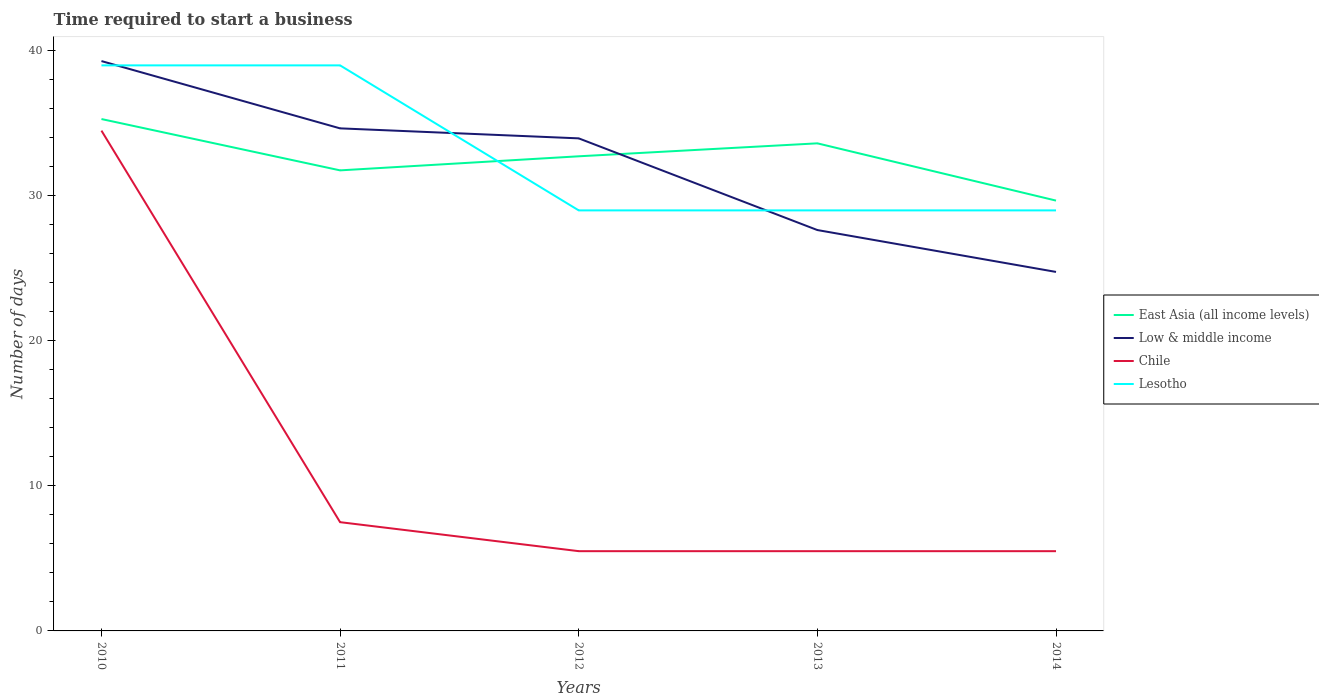How many different coloured lines are there?
Your answer should be very brief. 4. Is the number of lines equal to the number of legend labels?
Your answer should be very brief. Yes. Across all years, what is the maximum number of days required to start a business in East Asia (all income levels)?
Your answer should be compact. 29.68. What is the total number of days required to start a business in Low & middle income in the graph?
Your answer should be very brief. 5.33. Is the number of days required to start a business in Low & middle income strictly greater than the number of days required to start a business in Lesotho over the years?
Provide a short and direct response. No. How many lines are there?
Provide a succinct answer. 4. What is the difference between two consecutive major ticks on the Y-axis?
Your answer should be compact. 10. Are the values on the major ticks of Y-axis written in scientific E-notation?
Your answer should be very brief. No. Does the graph contain grids?
Give a very brief answer. No. How many legend labels are there?
Ensure brevity in your answer.  4. What is the title of the graph?
Offer a very short reply. Time required to start a business. Does "Isle of Man" appear as one of the legend labels in the graph?
Give a very brief answer. No. What is the label or title of the X-axis?
Offer a terse response. Years. What is the label or title of the Y-axis?
Your answer should be compact. Number of days. What is the Number of days in East Asia (all income levels) in 2010?
Provide a short and direct response. 35.3. What is the Number of days in Low & middle income in 2010?
Give a very brief answer. 39.3. What is the Number of days of Chile in 2010?
Your answer should be very brief. 34.5. What is the Number of days of Lesotho in 2010?
Provide a short and direct response. 39. What is the Number of days in East Asia (all income levels) in 2011?
Ensure brevity in your answer.  31.76. What is the Number of days of Low & middle income in 2011?
Offer a terse response. 34.66. What is the Number of days in Chile in 2011?
Provide a succinct answer. 7.5. What is the Number of days of East Asia (all income levels) in 2012?
Offer a very short reply. 32.73. What is the Number of days in Low & middle income in 2012?
Provide a short and direct response. 33.97. What is the Number of days in Chile in 2012?
Give a very brief answer. 5.5. What is the Number of days of East Asia (all income levels) in 2013?
Make the answer very short. 33.62. What is the Number of days in Low & middle income in 2013?
Your answer should be compact. 27.64. What is the Number of days in Chile in 2013?
Ensure brevity in your answer.  5.5. What is the Number of days of Lesotho in 2013?
Make the answer very short. 29. What is the Number of days of East Asia (all income levels) in 2014?
Offer a terse response. 29.68. What is the Number of days in Low & middle income in 2014?
Offer a terse response. 24.76. What is the Number of days of Lesotho in 2014?
Make the answer very short. 29. Across all years, what is the maximum Number of days of East Asia (all income levels)?
Your answer should be very brief. 35.3. Across all years, what is the maximum Number of days in Low & middle income?
Provide a short and direct response. 39.3. Across all years, what is the maximum Number of days in Chile?
Offer a very short reply. 34.5. Across all years, what is the maximum Number of days in Lesotho?
Provide a succinct answer. 39. Across all years, what is the minimum Number of days of East Asia (all income levels)?
Your answer should be compact. 29.68. Across all years, what is the minimum Number of days of Low & middle income?
Your answer should be compact. 24.76. What is the total Number of days in East Asia (all income levels) in the graph?
Provide a succinct answer. 163.09. What is the total Number of days in Low & middle income in the graph?
Offer a terse response. 160.32. What is the total Number of days in Chile in the graph?
Make the answer very short. 58.5. What is the total Number of days in Lesotho in the graph?
Make the answer very short. 165. What is the difference between the Number of days in East Asia (all income levels) in 2010 and that in 2011?
Your answer should be compact. 3.54. What is the difference between the Number of days in Low & middle income in 2010 and that in 2011?
Give a very brief answer. 4.64. What is the difference between the Number of days in Lesotho in 2010 and that in 2011?
Your answer should be very brief. 0. What is the difference between the Number of days of East Asia (all income levels) in 2010 and that in 2012?
Ensure brevity in your answer.  2.57. What is the difference between the Number of days in Low & middle income in 2010 and that in 2012?
Provide a short and direct response. 5.33. What is the difference between the Number of days of Chile in 2010 and that in 2012?
Keep it short and to the point. 29. What is the difference between the Number of days of Lesotho in 2010 and that in 2012?
Your response must be concise. 10. What is the difference between the Number of days in East Asia (all income levels) in 2010 and that in 2013?
Your response must be concise. 1.68. What is the difference between the Number of days in Low & middle income in 2010 and that in 2013?
Your response must be concise. 11.65. What is the difference between the Number of days in Chile in 2010 and that in 2013?
Your response must be concise. 29. What is the difference between the Number of days of Lesotho in 2010 and that in 2013?
Make the answer very short. 10. What is the difference between the Number of days in East Asia (all income levels) in 2010 and that in 2014?
Your response must be concise. 5.62. What is the difference between the Number of days of Low & middle income in 2010 and that in 2014?
Your answer should be very brief. 14.54. What is the difference between the Number of days in Lesotho in 2010 and that in 2014?
Make the answer very short. 10. What is the difference between the Number of days in East Asia (all income levels) in 2011 and that in 2012?
Keep it short and to the point. -0.97. What is the difference between the Number of days in Low & middle income in 2011 and that in 2012?
Ensure brevity in your answer.  0.69. What is the difference between the Number of days of Chile in 2011 and that in 2012?
Offer a terse response. 2. What is the difference between the Number of days of Lesotho in 2011 and that in 2012?
Your answer should be compact. 10. What is the difference between the Number of days in East Asia (all income levels) in 2011 and that in 2013?
Make the answer very short. -1.86. What is the difference between the Number of days in Low & middle income in 2011 and that in 2013?
Offer a very short reply. 7.01. What is the difference between the Number of days of Chile in 2011 and that in 2013?
Give a very brief answer. 2. What is the difference between the Number of days of Lesotho in 2011 and that in 2013?
Provide a succinct answer. 10. What is the difference between the Number of days in East Asia (all income levels) in 2011 and that in 2014?
Your response must be concise. 2.08. What is the difference between the Number of days in Low & middle income in 2011 and that in 2014?
Make the answer very short. 9.9. What is the difference between the Number of days of Chile in 2011 and that in 2014?
Ensure brevity in your answer.  2. What is the difference between the Number of days of Lesotho in 2011 and that in 2014?
Provide a succinct answer. 10. What is the difference between the Number of days of East Asia (all income levels) in 2012 and that in 2013?
Make the answer very short. -0.89. What is the difference between the Number of days of Low & middle income in 2012 and that in 2013?
Offer a terse response. 6.32. What is the difference between the Number of days in Lesotho in 2012 and that in 2013?
Provide a short and direct response. 0. What is the difference between the Number of days of East Asia (all income levels) in 2012 and that in 2014?
Offer a terse response. 3.05. What is the difference between the Number of days in Low & middle income in 2012 and that in 2014?
Your answer should be very brief. 9.21. What is the difference between the Number of days of Lesotho in 2012 and that in 2014?
Your response must be concise. 0. What is the difference between the Number of days in East Asia (all income levels) in 2013 and that in 2014?
Give a very brief answer. 3.95. What is the difference between the Number of days in Low & middle income in 2013 and that in 2014?
Give a very brief answer. 2.89. What is the difference between the Number of days of Chile in 2013 and that in 2014?
Offer a terse response. 0. What is the difference between the Number of days in Lesotho in 2013 and that in 2014?
Your answer should be compact. 0. What is the difference between the Number of days in East Asia (all income levels) in 2010 and the Number of days in Low & middle income in 2011?
Your answer should be very brief. 0.64. What is the difference between the Number of days in East Asia (all income levels) in 2010 and the Number of days in Chile in 2011?
Keep it short and to the point. 27.8. What is the difference between the Number of days in East Asia (all income levels) in 2010 and the Number of days in Lesotho in 2011?
Ensure brevity in your answer.  -3.7. What is the difference between the Number of days of Low & middle income in 2010 and the Number of days of Chile in 2011?
Provide a short and direct response. 31.8. What is the difference between the Number of days of Low & middle income in 2010 and the Number of days of Lesotho in 2011?
Your answer should be compact. 0.3. What is the difference between the Number of days in East Asia (all income levels) in 2010 and the Number of days in Low & middle income in 2012?
Offer a very short reply. 1.33. What is the difference between the Number of days of East Asia (all income levels) in 2010 and the Number of days of Chile in 2012?
Provide a short and direct response. 29.8. What is the difference between the Number of days in Low & middle income in 2010 and the Number of days in Chile in 2012?
Offer a very short reply. 33.8. What is the difference between the Number of days in Low & middle income in 2010 and the Number of days in Lesotho in 2012?
Your response must be concise. 10.3. What is the difference between the Number of days in East Asia (all income levels) in 2010 and the Number of days in Low & middle income in 2013?
Your answer should be very brief. 7.66. What is the difference between the Number of days in East Asia (all income levels) in 2010 and the Number of days in Chile in 2013?
Provide a succinct answer. 29.8. What is the difference between the Number of days in Low & middle income in 2010 and the Number of days in Chile in 2013?
Your answer should be compact. 33.8. What is the difference between the Number of days of Low & middle income in 2010 and the Number of days of Lesotho in 2013?
Provide a succinct answer. 10.3. What is the difference between the Number of days of Chile in 2010 and the Number of days of Lesotho in 2013?
Make the answer very short. 5.5. What is the difference between the Number of days in East Asia (all income levels) in 2010 and the Number of days in Low & middle income in 2014?
Your response must be concise. 10.54. What is the difference between the Number of days in East Asia (all income levels) in 2010 and the Number of days in Chile in 2014?
Keep it short and to the point. 29.8. What is the difference between the Number of days of Low & middle income in 2010 and the Number of days of Chile in 2014?
Ensure brevity in your answer.  33.8. What is the difference between the Number of days of Low & middle income in 2010 and the Number of days of Lesotho in 2014?
Provide a succinct answer. 10.3. What is the difference between the Number of days in Chile in 2010 and the Number of days in Lesotho in 2014?
Your answer should be compact. 5.5. What is the difference between the Number of days in East Asia (all income levels) in 2011 and the Number of days in Low & middle income in 2012?
Provide a succinct answer. -2.21. What is the difference between the Number of days in East Asia (all income levels) in 2011 and the Number of days in Chile in 2012?
Keep it short and to the point. 26.26. What is the difference between the Number of days of East Asia (all income levels) in 2011 and the Number of days of Lesotho in 2012?
Your answer should be compact. 2.76. What is the difference between the Number of days in Low & middle income in 2011 and the Number of days in Chile in 2012?
Provide a short and direct response. 29.16. What is the difference between the Number of days of Low & middle income in 2011 and the Number of days of Lesotho in 2012?
Provide a succinct answer. 5.66. What is the difference between the Number of days of Chile in 2011 and the Number of days of Lesotho in 2012?
Make the answer very short. -21.5. What is the difference between the Number of days of East Asia (all income levels) in 2011 and the Number of days of Low & middle income in 2013?
Provide a succinct answer. 4.12. What is the difference between the Number of days in East Asia (all income levels) in 2011 and the Number of days in Chile in 2013?
Provide a short and direct response. 26.26. What is the difference between the Number of days in East Asia (all income levels) in 2011 and the Number of days in Lesotho in 2013?
Make the answer very short. 2.76. What is the difference between the Number of days in Low & middle income in 2011 and the Number of days in Chile in 2013?
Your answer should be compact. 29.16. What is the difference between the Number of days of Low & middle income in 2011 and the Number of days of Lesotho in 2013?
Your response must be concise. 5.66. What is the difference between the Number of days of Chile in 2011 and the Number of days of Lesotho in 2013?
Make the answer very short. -21.5. What is the difference between the Number of days of East Asia (all income levels) in 2011 and the Number of days of Low & middle income in 2014?
Provide a succinct answer. 7. What is the difference between the Number of days of East Asia (all income levels) in 2011 and the Number of days of Chile in 2014?
Ensure brevity in your answer.  26.26. What is the difference between the Number of days in East Asia (all income levels) in 2011 and the Number of days in Lesotho in 2014?
Ensure brevity in your answer.  2.76. What is the difference between the Number of days of Low & middle income in 2011 and the Number of days of Chile in 2014?
Offer a very short reply. 29.16. What is the difference between the Number of days in Low & middle income in 2011 and the Number of days in Lesotho in 2014?
Your answer should be very brief. 5.66. What is the difference between the Number of days of Chile in 2011 and the Number of days of Lesotho in 2014?
Give a very brief answer. -21.5. What is the difference between the Number of days of East Asia (all income levels) in 2012 and the Number of days of Low & middle income in 2013?
Provide a short and direct response. 5.09. What is the difference between the Number of days in East Asia (all income levels) in 2012 and the Number of days in Chile in 2013?
Your answer should be very brief. 27.23. What is the difference between the Number of days of East Asia (all income levels) in 2012 and the Number of days of Lesotho in 2013?
Offer a very short reply. 3.73. What is the difference between the Number of days of Low & middle income in 2012 and the Number of days of Chile in 2013?
Give a very brief answer. 28.47. What is the difference between the Number of days in Low & middle income in 2012 and the Number of days in Lesotho in 2013?
Offer a terse response. 4.97. What is the difference between the Number of days of Chile in 2012 and the Number of days of Lesotho in 2013?
Offer a very short reply. -23.5. What is the difference between the Number of days in East Asia (all income levels) in 2012 and the Number of days in Low & middle income in 2014?
Provide a short and direct response. 7.97. What is the difference between the Number of days in East Asia (all income levels) in 2012 and the Number of days in Chile in 2014?
Your answer should be compact. 27.23. What is the difference between the Number of days in East Asia (all income levels) in 2012 and the Number of days in Lesotho in 2014?
Provide a short and direct response. 3.73. What is the difference between the Number of days in Low & middle income in 2012 and the Number of days in Chile in 2014?
Your response must be concise. 28.47. What is the difference between the Number of days in Low & middle income in 2012 and the Number of days in Lesotho in 2014?
Ensure brevity in your answer.  4.97. What is the difference between the Number of days of Chile in 2012 and the Number of days of Lesotho in 2014?
Ensure brevity in your answer.  -23.5. What is the difference between the Number of days in East Asia (all income levels) in 2013 and the Number of days in Low & middle income in 2014?
Offer a very short reply. 8.87. What is the difference between the Number of days of East Asia (all income levels) in 2013 and the Number of days of Chile in 2014?
Keep it short and to the point. 28.12. What is the difference between the Number of days in East Asia (all income levels) in 2013 and the Number of days in Lesotho in 2014?
Your answer should be very brief. 4.62. What is the difference between the Number of days in Low & middle income in 2013 and the Number of days in Chile in 2014?
Make the answer very short. 22.14. What is the difference between the Number of days of Low & middle income in 2013 and the Number of days of Lesotho in 2014?
Give a very brief answer. -1.36. What is the difference between the Number of days of Chile in 2013 and the Number of days of Lesotho in 2014?
Make the answer very short. -23.5. What is the average Number of days of East Asia (all income levels) per year?
Your response must be concise. 32.62. What is the average Number of days of Low & middle income per year?
Give a very brief answer. 32.06. What is the average Number of days of Chile per year?
Provide a succinct answer. 11.7. In the year 2010, what is the difference between the Number of days in East Asia (all income levels) and Number of days in Low & middle income?
Provide a succinct answer. -4. In the year 2010, what is the difference between the Number of days of East Asia (all income levels) and Number of days of Chile?
Your answer should be compact. 0.8. In the year 2010, what is the difference between the Number of days in East Asia (all income levels) and Number of days in Lesotho?
Your response must be concise. -3.7. In the year 2010, what is the difference between the Number of days of Low & middle income and Number of days of Chile?
Offer a very short reply. 4.8. In the year 2010, what is the difference between the Number of days in Low & middle income and Number of days in Lesotho?
Provide a short and direct response. 0.3. In the year 2011, what is the difference between the Number of days in East Asia (all income levels) and Number of days in Low & middle income?
Your response must be concise. -2.9. In the year 2011, what is the difference between the Number of days in East Asia (all income levels) and Number of days in Chile?
Your answer should be very brief. 24.26. In the year 2011, what is the difference between the Number of days of East Asia (all income levels) and Number of days of Lesotho?
Your response must be concise. -7.24. In the year 2011, what is the difference between the Number of days of Low & middle income and Number of days of Chile?
Give a very brief answer. 27.16. In the year 2011, what is the difference between the Number of days in Low & middle income and Number of days in Lesotho?
Provide a succinct answer. -4.34. In the year 2011, what is the difference between the Number of days in Chile and Number of days in Lesotho?
Keep it short and to the point. -31.5. In the year 2012, what is the difference between the Number of days in East Asia (all income levels) and Number of days in Low & middle income?
Provide a succinct answer. -1.24. In the year 2012, what is the difference between the Number of days in East Asia (all income levels) and Number of days in Chile?
Give a very brief answer. 27.23. In the year 2012, what is the difference between the Number of days in East Asia (all income levels) and Number of days in Lesotho?
Your response must be concise. 3.73. In the year 2012, what is the difference between the Number of days of Low & middle income and Number of days of Chile?
Give a very brief answer. 28.47. In the year 2012, what is the difference between the Number of days in Low & middle income and Number of days in Lesotho?
Make the answer very short. 4.97. In the year 2012, what is the difference between the Number of days of Chile and Number of days of Lesotho?
Offer a very short reply. -23.5. In the year 2013, what is the difference between the Number of days in East Asia (all income levels) and Number of days in Low & middle income?
Your response must be concise. 5.98. In the year 2013, what is the difference between the Number of days in East Asia (all income levels) and Number of days in Chile?
Your answer should be compact. 28.12. In the year 2013, what is the difference between the Number of days in East Asia (all income levels) and Number of days in Lesotho?
Keep it short and to the point. 4.62. In the year 2013, what is the difference between the Number of days in Low & middle income and Number of days in Chile?
Offer a very short reply. 22.14. In the year 2013, what is the difference between the Number of days of Low & middle income and Number of days of Lesotho?
Give a very brief answer. -1.36. In the year 2013, what is the difference between the Number of days in Chile and Number of days in Lesotho?
Ensure brevity in your answer.  -23.5. In the year 2014, what is the difference between the Number of days in East Asia (all income levels) and Number of days in Low & middle income?
Offer a terse response. 4.92. In the year 2014, what is the difference between the Number of days of East Asia (all income levels) and Number of days of Chile?
Your response must be concise. 24.18. In the year 2014, what is the difference between the Number of days of East Asia (all income levels) and Number of days of Lesotho?
Ensure brevity in your answer.  0.68. In the year 2014, what is the difference between the Number of days of Low & middle income and Number of days of Chile?
Offer a terse response. 19.26. In the year 2014, what is the difference between the Number of days of Low & middle income and Number of days of Lesotho?
Offer a terse response. -4.24. In the year 2014, what is the difference between the Number of days of Chile and Number of days of Lesotho?
Give a very brief answer. -23.5. What is the ratio of the Number of days in East Asia (all income levels) in 2010 to that in 2011?
Your response must be concise. 1.11. What is the ratio of the Number of days in Low & middle income in 2010 to that in 2011?
Keep it short and to the point. 1.13. What is the ratio of the Number of days of East Asia (all income levels) in 2010 to that in 2012?
Offer a very short reply. 1.08. What is the ratio of the Number of days of Low & middle income in 2010 to that in 2012?
Offer a very short reply. 1.16. What is the ratio of the Number of days of Chile in 2010 to that in 2012?
Make the answer very short. 6.27. What is the ratio of the Number of days in Lesotho in 2010 to that in 2012?
Provide a succinct answer. 1.34. What is the ratio of the Number of days in East Asia (all income levels) in 2010 to that in 2013?
Your answer should be very brief. 1.05. What is the ratio of the Number of days of Low & middle income in 2010 to that in 2013?
Offer a terse response. 1.42. What is the ratio of the Number of days of Chile in 2010 to that in 2013?
Ensure brevity in your answer.  6.27. What is the ratio of the Number of days in Lesotho in 2010 to that in 2013?
Your answer should be compact. 1.34. What is the ratio of the Number of days of East Asia (all income levels) in 2010 to that in 2014?
Make the answer very short. 1.19. What is the ratio of the Number of days in Low & middle income in 2010 to that in 2014?
Offer a very short reply. 1.59. What is the ratio of the Number of days in Chile in 2010 to that in 2014?
Offer a terse response. 6.27. What is the ratio of the Number of days of Lesotho in 2010 to that in 2014?
Offer a terse response. 1.34. What is the ratio of the Number of days of East Asia (all income levels) in 2011 to that in 2012?
Offer a very short reply. 0.97. What is the ratio of the Number of days in Low & middle income in 2011 to that in 2012?
Ensure brevity in your answer.  1.02. What is the ratio of the Number of days of Chile in 2011 to that in 2012?
Ensure brevity in your answer.  1.36. What is the ratio of the Number of days in Lesotho in 2011 to that in 2012?
Offer a very short reply. 1.34. What is the ratio of the Number of days in East Asia (all income levels) in 2011 to that in 2013?
Keep it short and to the point. 0.94. What is the ratio of the Number of days of Low & middle income in 2011 to that in 2013?
Make the answer very short. 1.25. What is the ratio of the Number of days in Chile in 2011 to that in 2013?
Provide a short and direct response. 1.36. What is the ratio of the Number of days of Lesotho in 2011 to that in 2013?
Keep it short and to the point. 1.34. What is the ratio of the Number of days in East Asia (all income levels) in 2011 to that in 2014?
Offer a very short reply. 1.07. What is the ratio of the Number of days of Low & middle income in 2011 to that in 2014?
Provide a short and direct response. 1.4. What is the ratio of the Number of days of Chile in 2011 to that in 2014?
Give a very brief answer. 1.36. What is the ratio of the Number of days of Lesotho in 2011 to that in 2014?
Provide a short and direct response. 1.34. What is the ratio of the Number of days of East Asia (all income levels) in 2012 to that in 2013?
Keep it short and to the point. 0.97. What is the ratio of the Number of days in Low & middle income in 2012 to that in 2013?
Provide a short and direct response. 1.23. What is the ratio of the Number of days in Lesotho in 2012 to that in 2013?
Provide a short and direct response. 1. What is the ratio of the Number of days of East Asia (all income levels) in 2012 to that in 2014?
Provide a succinct answer. 1.1. What is the ratio of the Number of days in Low & middle income in 2012 to that in 2014?
Your response must be concise. 1.37. What is the ratio of the Number of days in Lesotho in 2012 to that in 2014?
Your response must be concise. 1. What is the ratio of the Number of days in East Asia (all income levels) in 2013 to that in 2014?
Offer a very short reply. 1.13. What is the ratio of the Number of days of Low & middle income in 2013 to that in 2014?
Your response must be concise. 1.12. What is the ratio of the Number of days in Lesotho in 2013 to that in 2014?
Ensure brevity in your answer.  1. What is the difference between the highest and the second highest Number of days in East Asia (all income levels)?
Provide a succinct answer. 1.68. What is the difference between the highest and the second highest Number of days in Low & middle income?
Your answer should be very brief. 4.64. What is the difference between the highest and the second highest Number of days in Chile?
Make the answer very short. 27. What is the difference between the highest and the lowest Number of days of East Asia (all income levels)?
Give a very brief answer. 5.62. What is the difference between the highest and the lowest Number of days in Low & middle income?
Offer a very short reply. 14.54. What is the difference between the highest and the lowest Number of days of Chile?
Ensure brevity in your answer.  29. What is the difference between the highest and the lowest Number of days of Lesotho?
Your response must be concise. 10. 